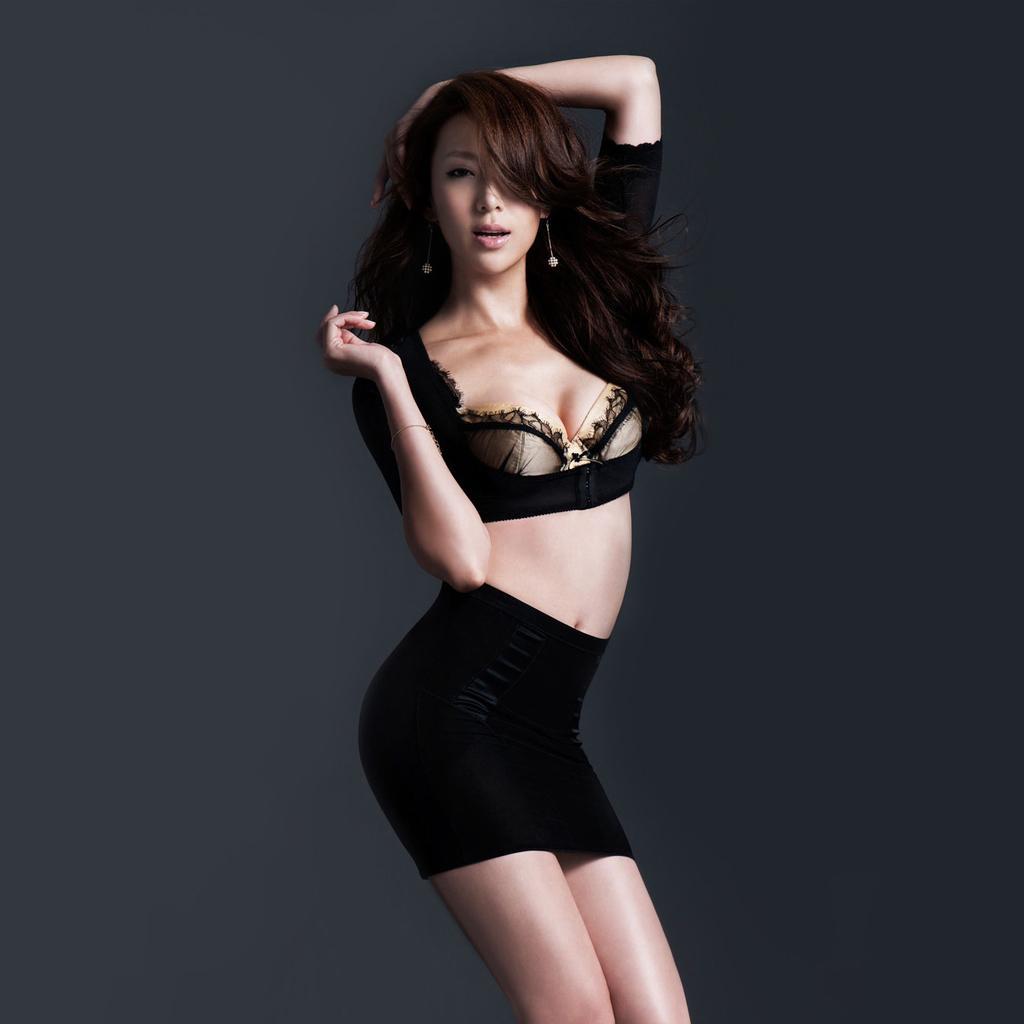How would you summarize this image in a sentence or two? In this image we can see a girl is standing and in the background the image is in gray color. 